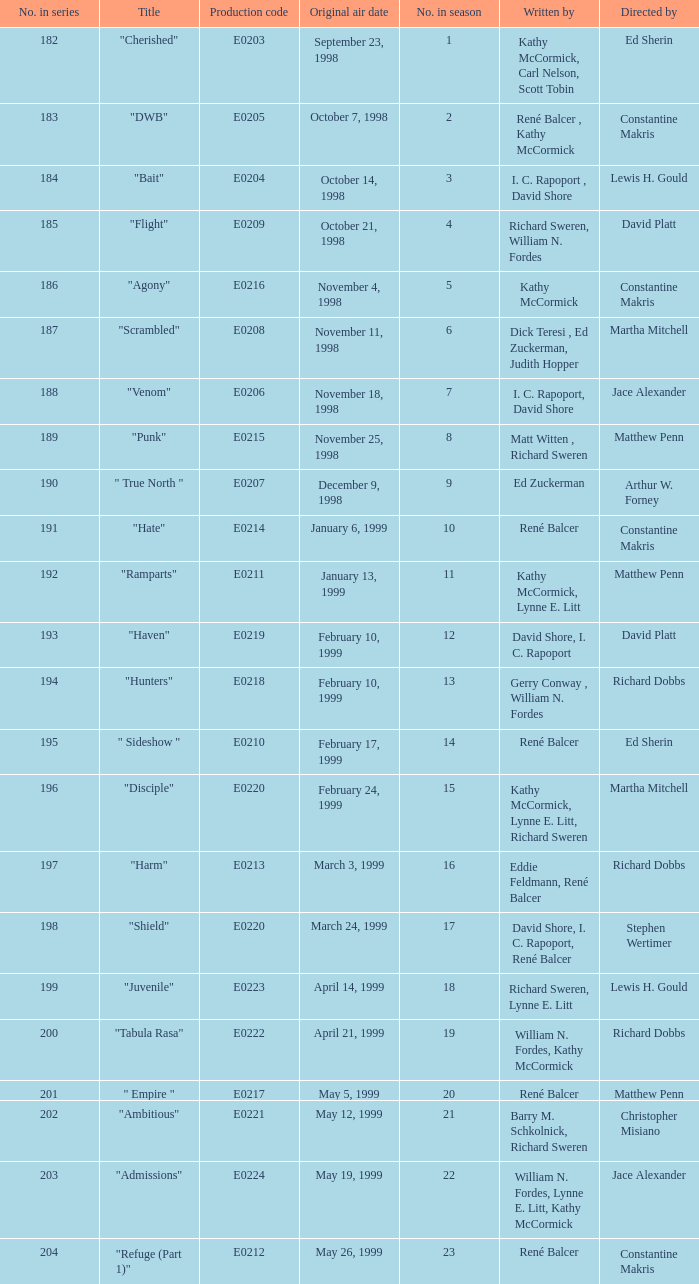The episode with the original air date January 6, 1999, has what production code? E0214. 